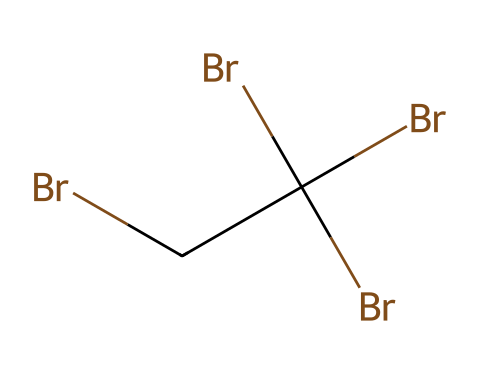how many bromine atoms are present in this compound? The provided SMILES representation shows four 'Br' symbols, indicating that there are four bromine atoms present.
Answer: four what type of bonding is primarily seen in this compound? The presence of multiple bromine atoms bonded to carbon indicates that this compound predominantly features covalent bonding.
Answer: covalent what is the carbon-to-bromine ratio in this compound? There are four bromine atoms and one carbon atom in the compound, resulting in a ratio of 4:1 for carbon to bromine.
Answer: 4:1 does this chemical contain any functional groups? The structure shows no distinct functional groups like -OH or -NH groups; it primarily consists of bromine and carbon, suggesting it lacks typical functional groups.
Answer: no what effect might the high bromine content have on the properties of the compound? The high bromine content is likely to contribute to flame retardant properties, as brominated compounds are known for their ability to inhibit combustion.
Answer: flame retardant how many tertiary carbon atoms are present in this compound? There is one central carbon atom bonded to three bromine atoms, making it a tertiary carbon since it is bonded to three other carbon or atom groups.
Answer: one what is the main element type used in flame retardants in this structure? This compound heavily relies on bromine, a halogen, which is a key element in many flame retardant formulations due to its fire-resistant properties.
Answer: bromine 